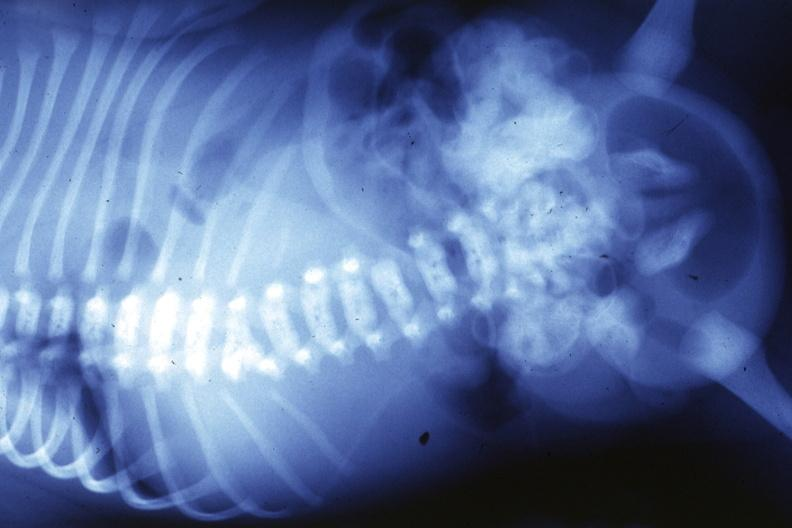does this image show x-ray infant?
Answer the question using a single word or phrase. Yes 